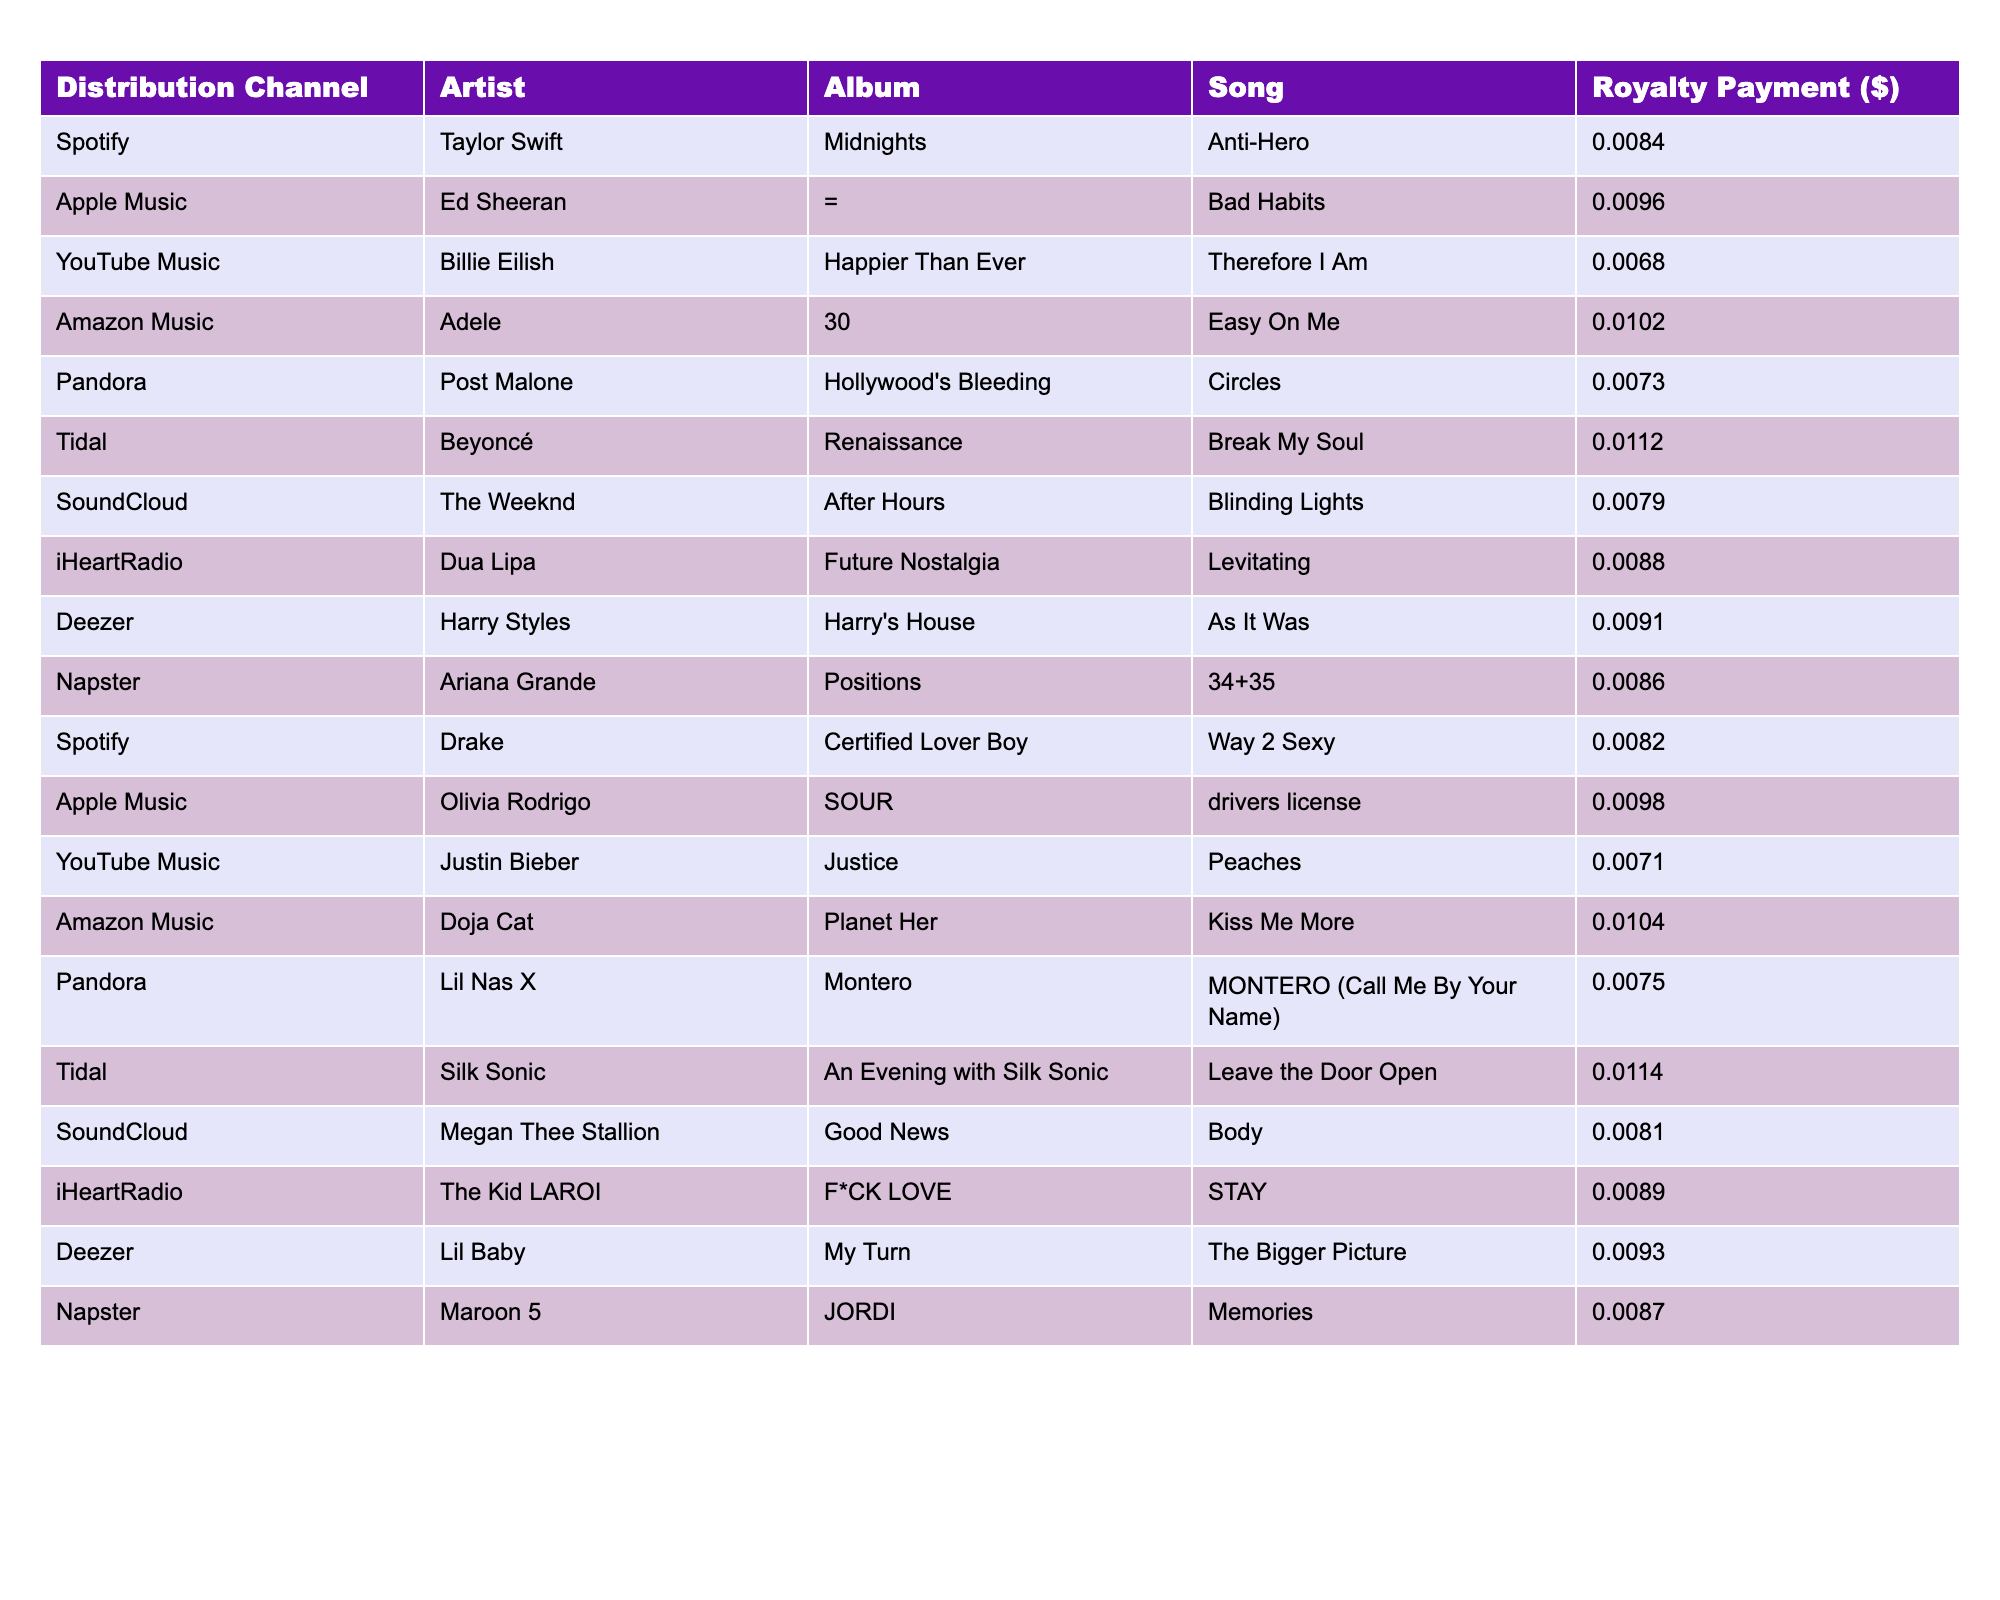What is the highest royalty payment amount in the table? By scanning through the table, we see that the highest royalty payment is associated with the song "Leave the Door Open" by Silk Sonic, which has a payment of $0.0114.
Answer: $0.0114 Which artist received a royalty payment of $0.0096? Looking at the table, Ed Sheeran is the artist listed with a royalty payment amount of $0.0096 for the song "Bad Habits" on Apple Music.
Answer: Ed Sheeran What is the total royalty payment for Taylor Swift and Adele combined? The table shows that Taylor Swift received $0.0084 and Adele received $0.0102. Adding these amounts: $0.0084 + $0.0102 = $0.0186.
Answer: $0.0186 Did Beyoncé have the highest royalty payment among all artists? After checking the payments in the table, Beyoncé received $0.0112, which is higher than all other amounts listed for different artists. Therefore, yes, Beyoncé had the highest payment.
Answer: Yes Which distribution channel yielded the highest royalty payment for a song? The highest payment recorded in the table is $0.0114 from the Tidal channel for the song "Leave the Door Open" by Silk Sonic. We identify this by comparing all channel payments.
Answer: Tidal What is the average royalty payment across all artists in the table? The payments listed are $0.0084, $0.0096, $0.0068, $0.0102, $0.0073, $0.0112, $0.0079, $0.0088, $0.0091, $0.0086, $0.0082, $0.0098, $0.0071, $0.0104, $0.0075, $0.0114, $0.0081, $0.0089, $0.0093, $0.0087. Adding these together gives $0.1680, and dividing by the number of entries (20) gives an average of $0.0084.
Answer: $0.0084 How many artists received royalty payments from the Amazon Music channel? According to the table, there are two entries for Amazon Music: Adele with "Easy On Me" and Doja Cat with "Kiss Me More". Counting those gives us a total of two artists.
Answer: 2 Which artist's song on YouTube Music had the lowest royalty payment? The table indicates that Justin Bieber's song "Peaches" has the lowest royalty payment on YouTube Music at $0.0071. We can verify this by comparing the payments listed for each artist on this channel.
Answer: Justin Bieber Is there any artist who received the same royalty payment amount across different distribution channels? Reviewing the data, no artists appear to have the same royalty payment amount for different channels; each entry is unique in payment amount.
Answer: No What is the difference between the highest and lowest royalty payments? The highest payment is $0.0114 (Beyoncé - Tidal) and the lowest is $0.0068 (Billie Eilish - YouTube Music). Subtracting gives us $0.0114 - $0.0068 = $0.0046.
Answer: $0.0046 